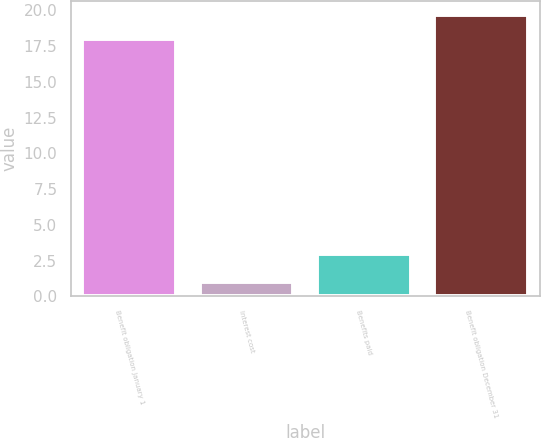Convert chart to OTSL. <chart><loc_0><loc_0><loc_500><loc_500><bar_chart><fcel>Benefit obligation January 1<fcel>Interest cost<fcel>Benefits paid<fcel>Benefit obligation December 31<nl><fcel>18<fcel>1<fcel>3<fcel>19.7<nl></chart> 